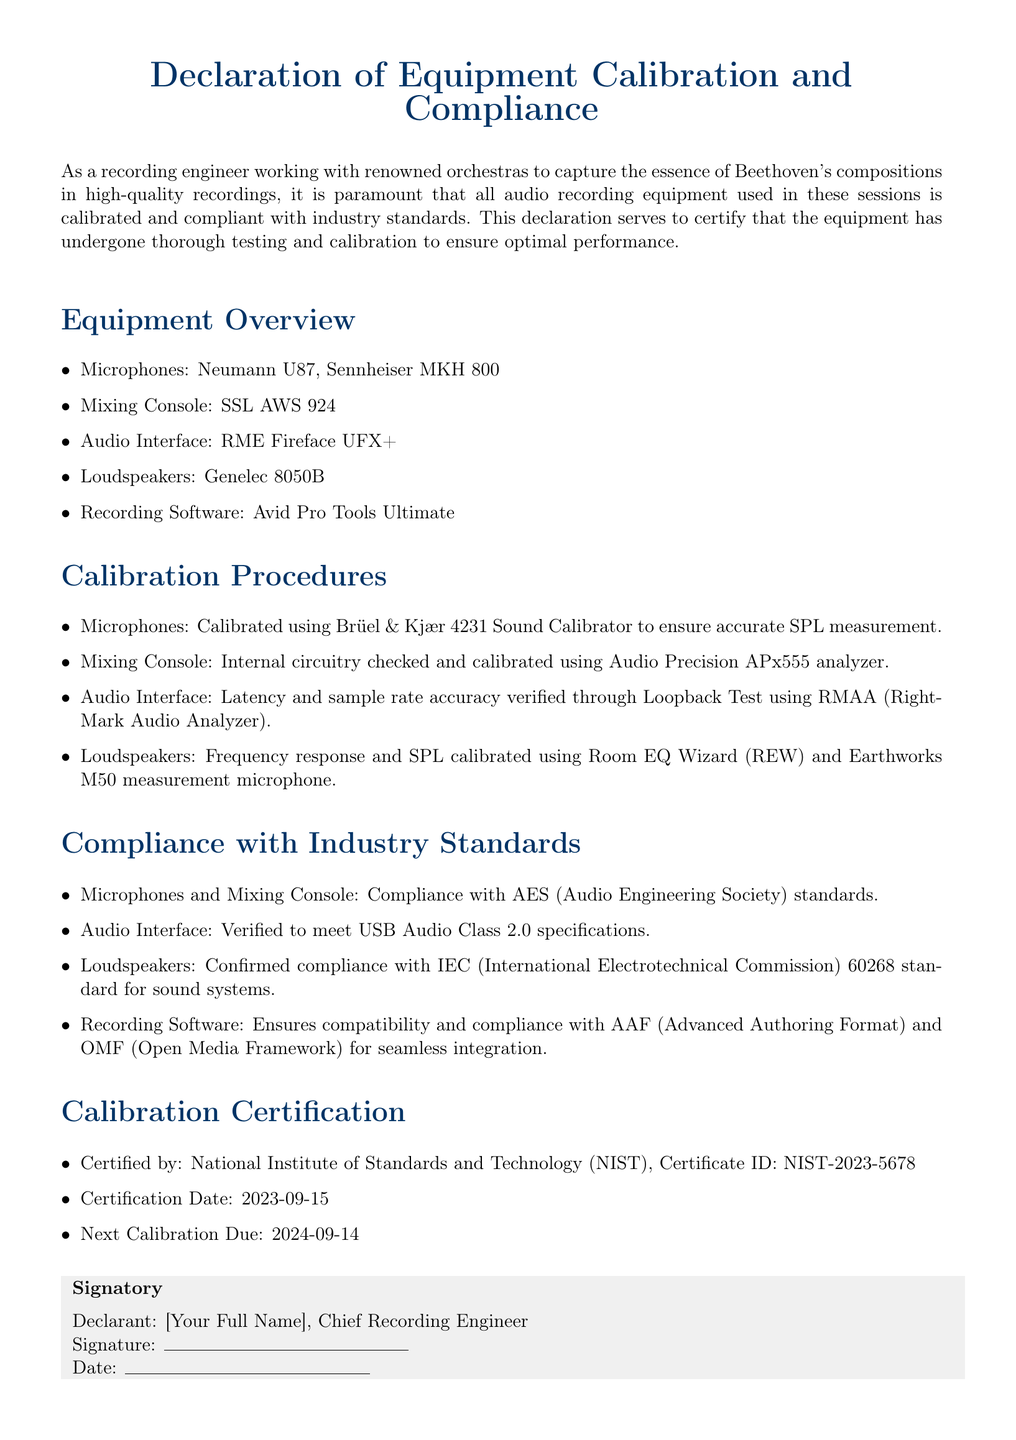What is the title of the document? The title is stated at the beginning of the document as the "Declaration of Equipment Calibration and Compliance."
Answer: Declaration of Equipment Calibration and Compliance Who certified the calibration of the equipment? The certification is provided by the National Institute of Standards and Technology (NIST).
Answer: National Institute of Standards and Technology (NIST) What is the Certification ID for the calibration? The Certification ID is mentioned in the Calibration Certification section of the document.
Answer: NIST-2023-5678 When is the next calibration due? The document specifies the date for the next calibration in the Calibration Certification section.
Answer: 2024-09-14 Which microphones are listed in the Equipment Overview? The document lists specific microphones in the Equipment Overview.
Answer: Neumann U87, Sennheiser MKH 800 What standard do the microphones and mixing console comply with? The compliance information for microphones and mixing console is detailed under Compliance with Industry Standards.
Answer: AES How was the audio interface's latency verified? The document describes the method for verification of latency in the Calibration Procedures section.
Answer: Loopback Test using RMAA What is the date of calibration certification? The Certification Date is provided in the Calibration Certification section of the document.
Answer: 2023-09-15 What signature is required for the declaration? The document indicates a role related to the signatory of the declaration.
Answer: Chief Recording Engineer 